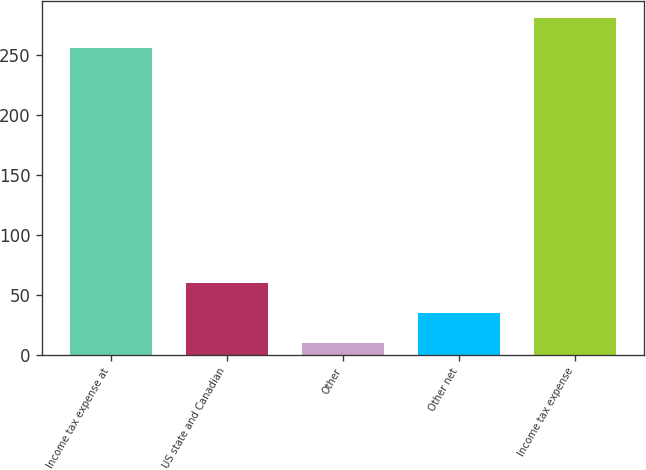Convert chart. <chart><loc_0><loc_0><loc_500><loc_500><bar_chart><fcel>Income tax expense at<fcel>US state and Canadian<fcel>Other<fcel>Other net<fcel>Income tax expense<nl><fcel>256<fcel>60<fcel>10<fcel>35<fcel>281<nl></chart> 